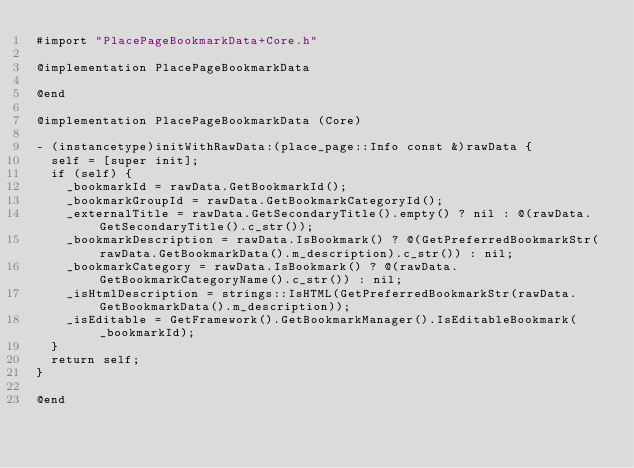<code> <loc_0><loc_0><loc_500><loc_500><_ObjectiveC_>#import "PlacePageBookmarkData+Core.h"

@implementation PlacePageBookmarkData

@end

@implementation PlacePageBookmarkData (Core)

- (instancetype)initWithRawData:(place_page::Info const &)rawData {
  self = [super init];
  if (self) {
    _bookmarkId = rawData.GetBookmarkId();
    _bookmarkGroupId = rawData.GetBookmarkCategoryId();
    _externalTitle = rawData.GetSecondaryTitle().empty() ? nil : @(rawData.GetSecondaryTitle().c_str());
    _bookmarkDescription = rawData.IsBookmark() ? @(GetPreferredBookmarkStr(rawData.GetBookmarkData().m_description).c_str()) : nil;
    _bookmarkCategory = rawData.IsBookmark() ? @(rawData.GetBookmarkCategoryName().c_str()) : nil;
    _isHtmlDescription = strings::IsHTML(GetPreferredBookmarkStr(rawData.GetBookmarkData().m_description));
    _isEditable = GetFramework().GetBookmarkManager().IsEditableBookmark(_bookmarkId);
  }
  return self;
}

@end
</code> 